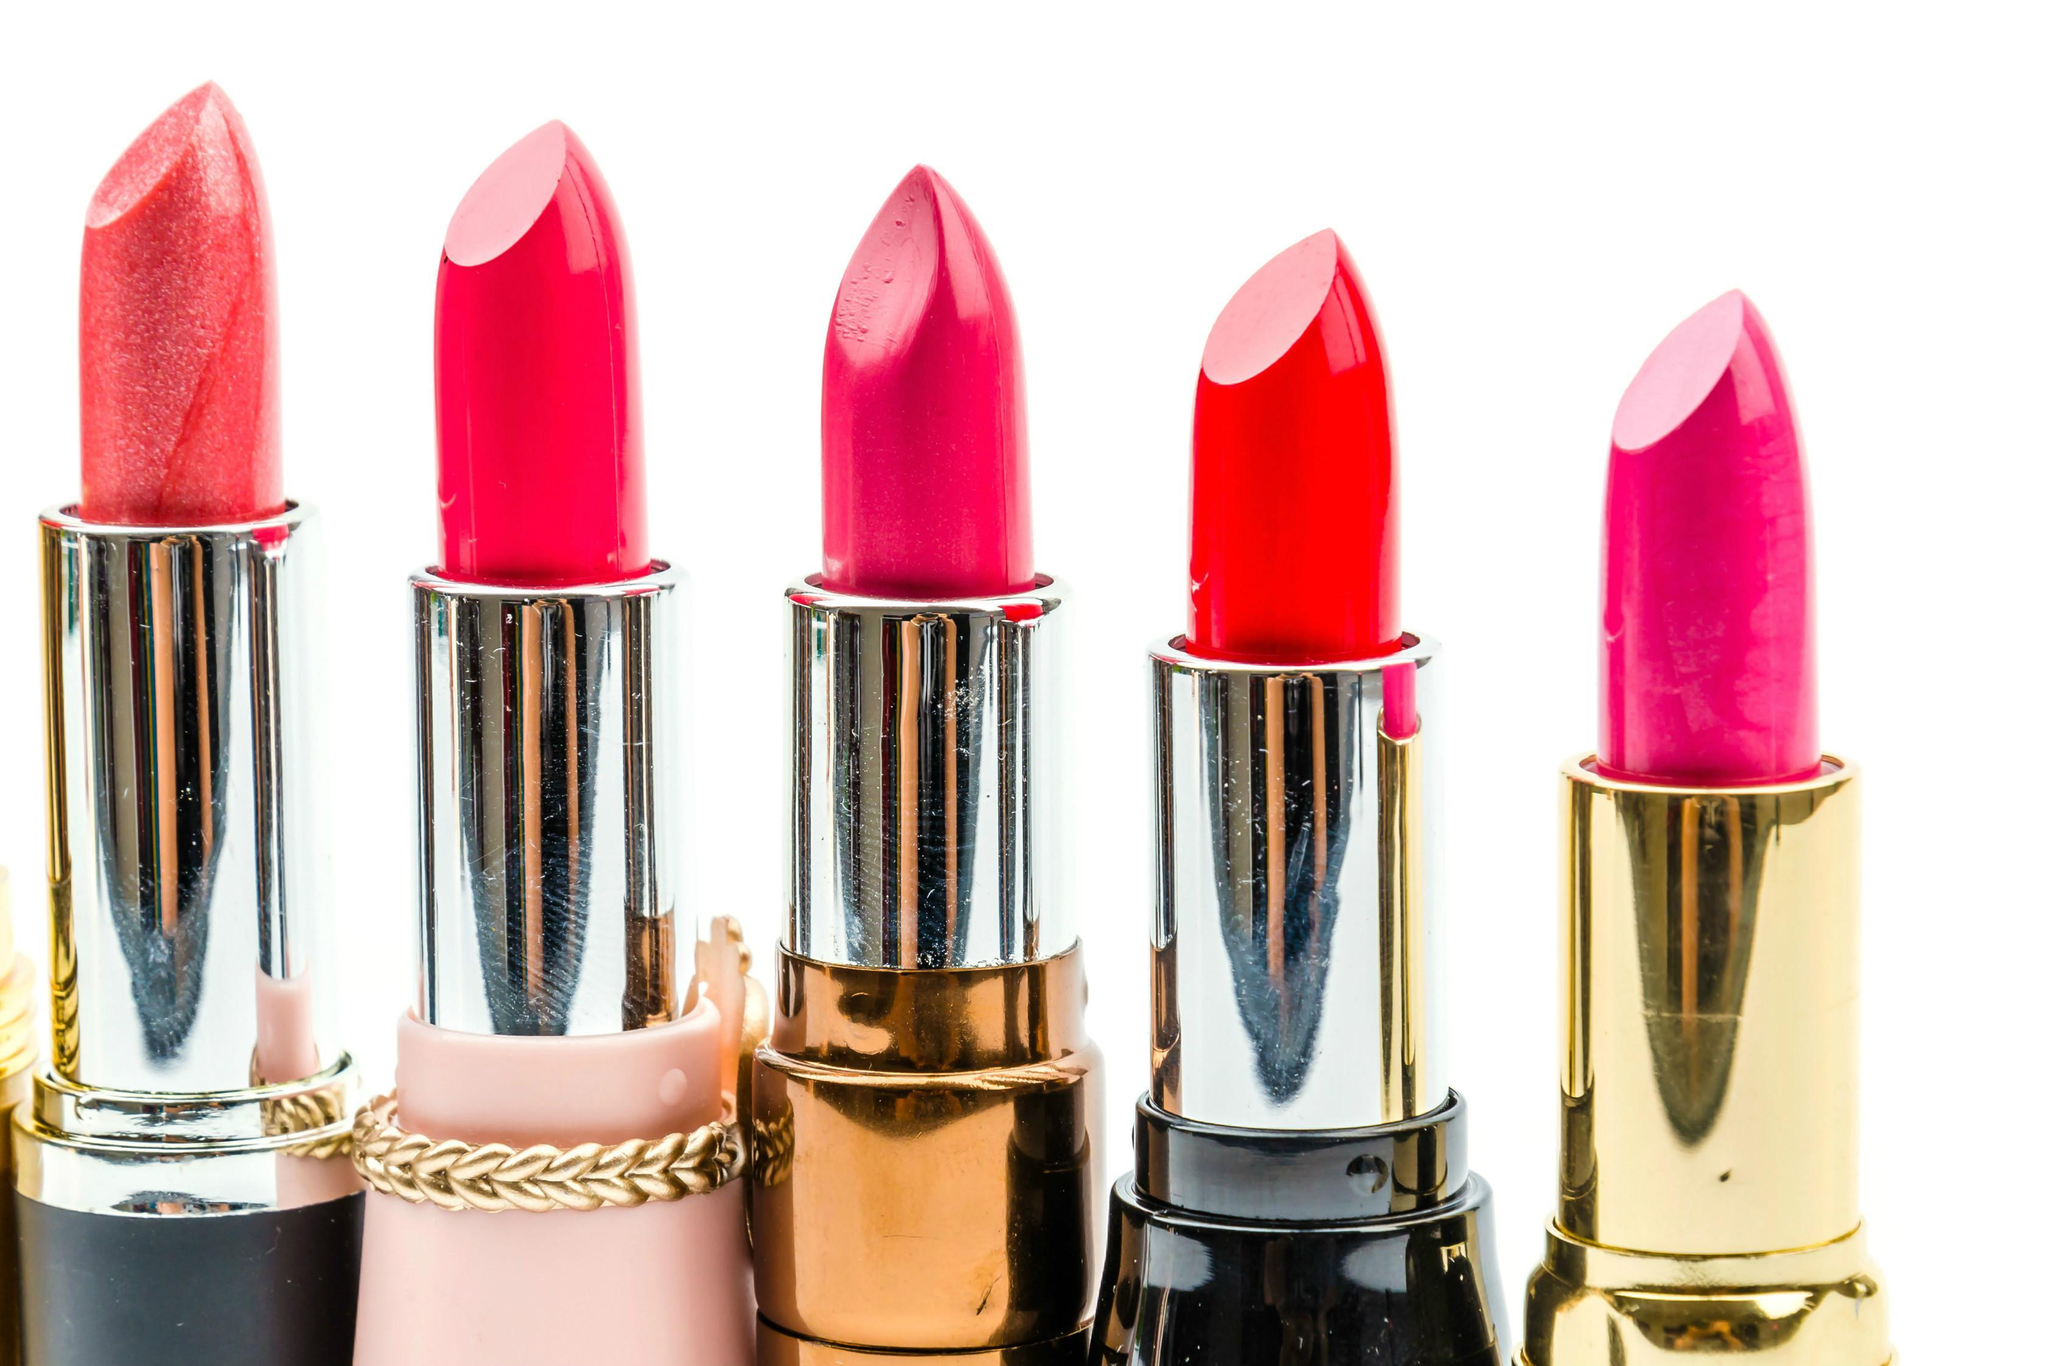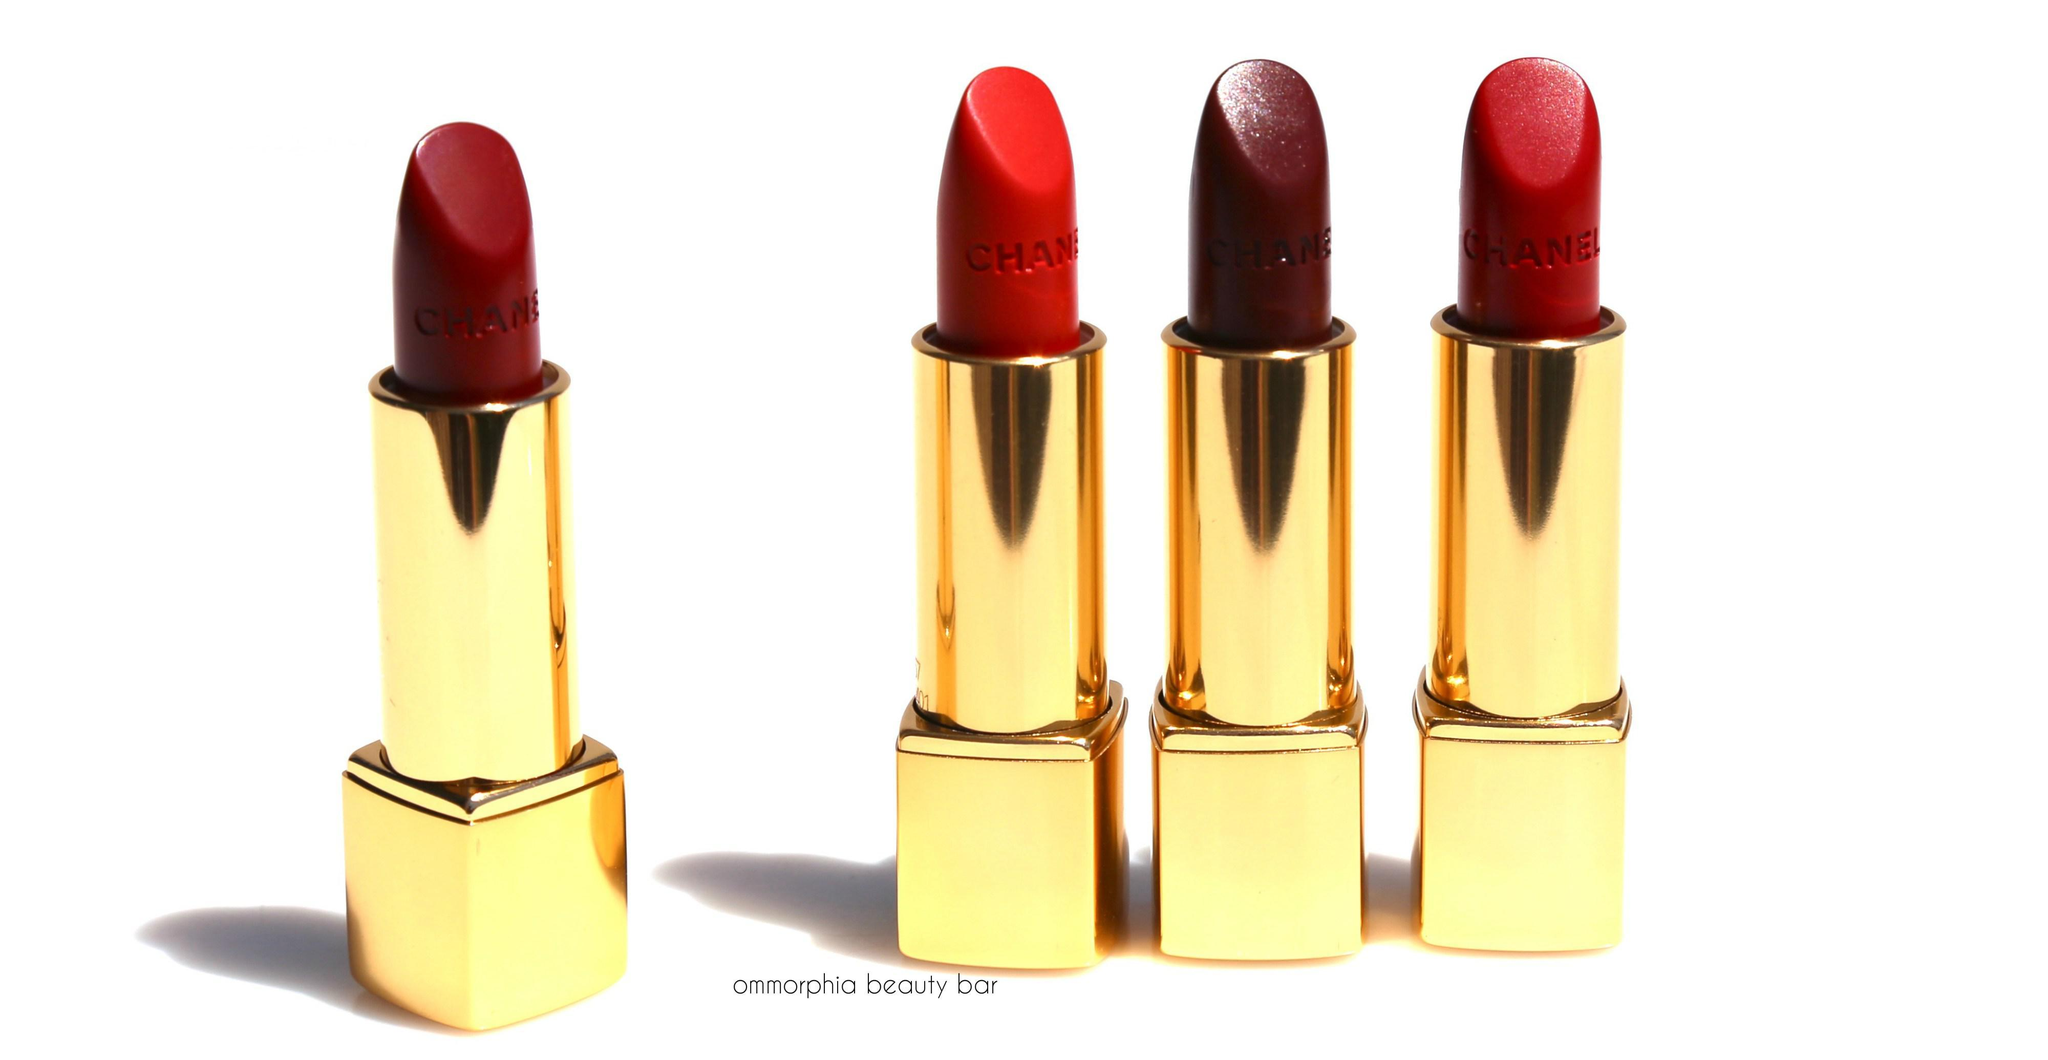The first image is the image on the left, the second image is the image on the right. Assess this claim about the two images: "One image shows a single red upright lipstick next to its upright cover.". Correct or not? Answer yes or no. No. The first image is the image on the left, the second image is the image on the right. Evaluate the accuracy of this statement regarding the images: "One images shows at least five tubes of lipstick with all the caps off lined up in a row.". Is it true? Answer yes or no. Yes. 